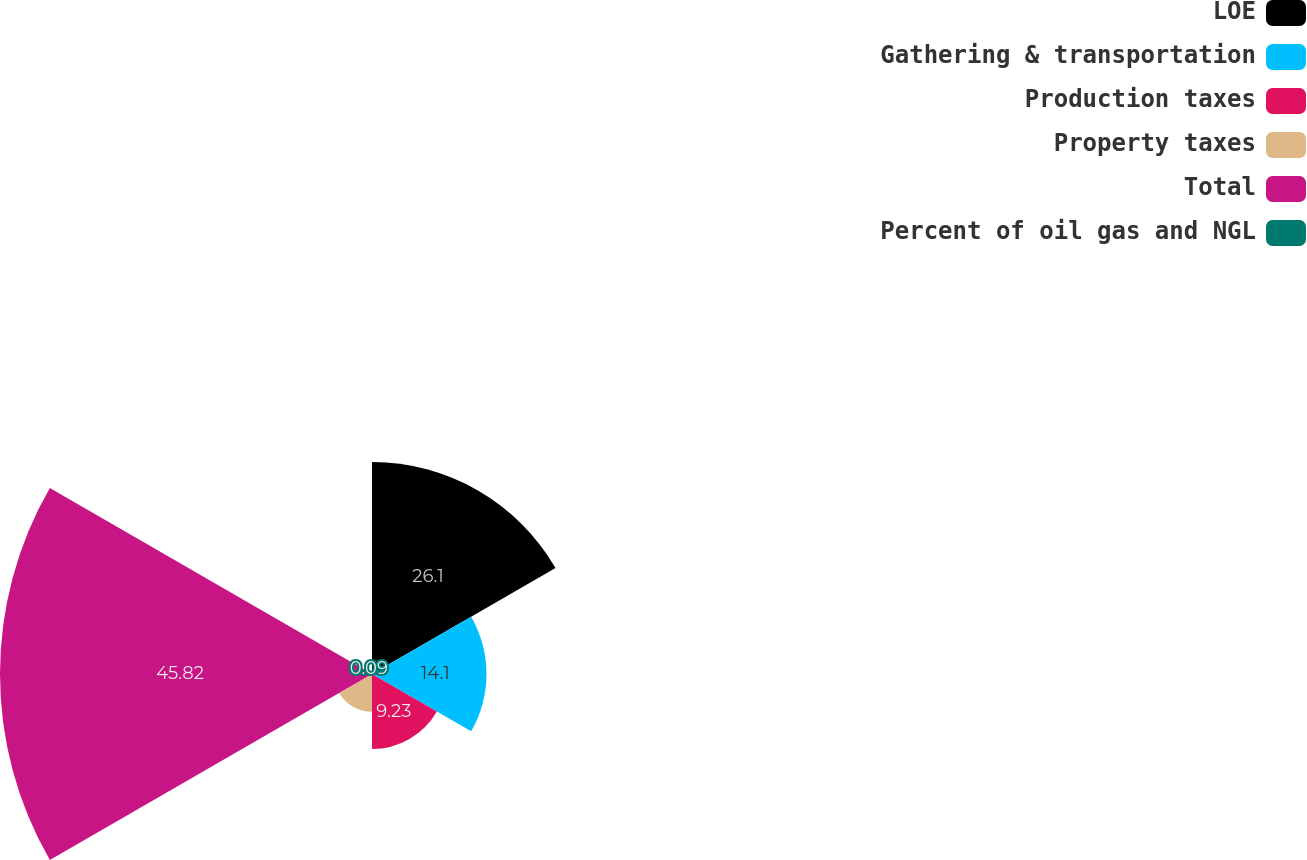Convert chart. <chart><loc_0><loc_0><loc_500><loc_500><pie_chart><fcel>LOE<fcel>Gathering & transportation<fcel>Production taxes<fcel>Property taxes<fcel>Total<fcel>Percent of oil gas and NGL<nl><fcel>26.1%<fcel>14.1%<fcel>9.23%<fcel>4.66%<fcel>45.82%<fcel>0.09%<nl></chart> 